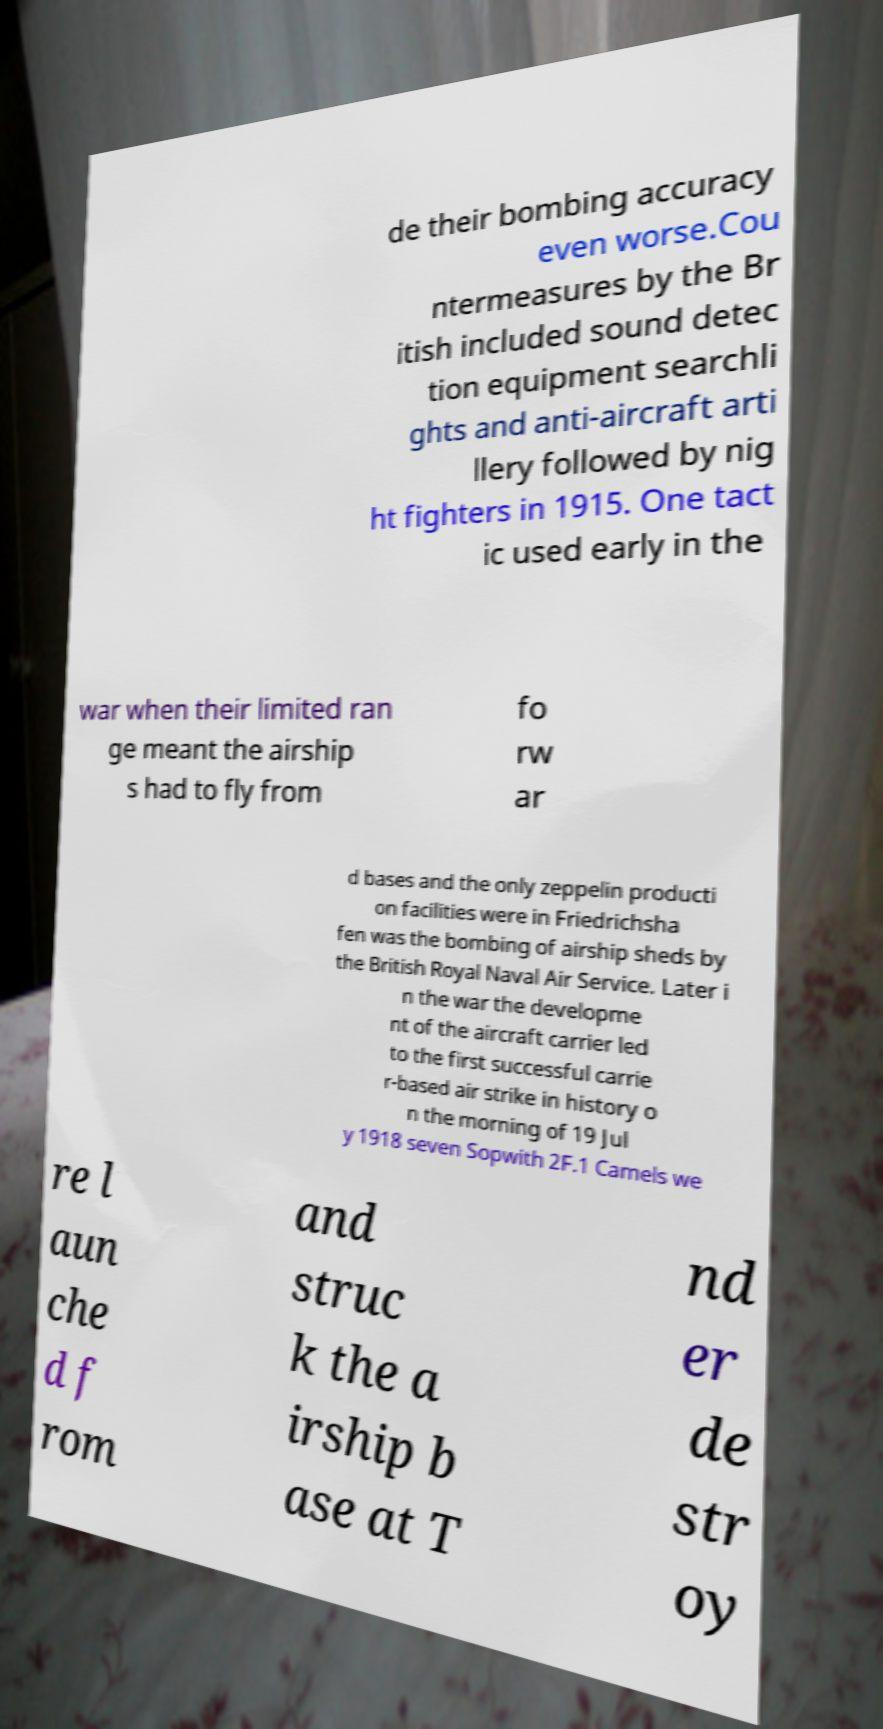Could you extract and type out the text from this image? de their bombing accuracy even worse.Cou ntermeasures by the Br itish included sound detec tion equipment searchli ghts and anti-aircraft arti llery followed by nig ht fighters in 1915. One tact ic used early in the war when their limited ran ge meant the airship s had to fly from fo rw ar d bases and the only zeppelin producti on facilities were in Friedrichsha fen was the bombing of airship sheds by the British Royal Naval Air Service. Later i n the war the developme nt of the aircraft carrier led to the first successful carrie r-based air strike in history o n the morning of 19 Jul y 1918 seven Sopwith 2F.1 Camels we re l aun che d f rom and struc k the a irship b ase at T nd er de str oy 